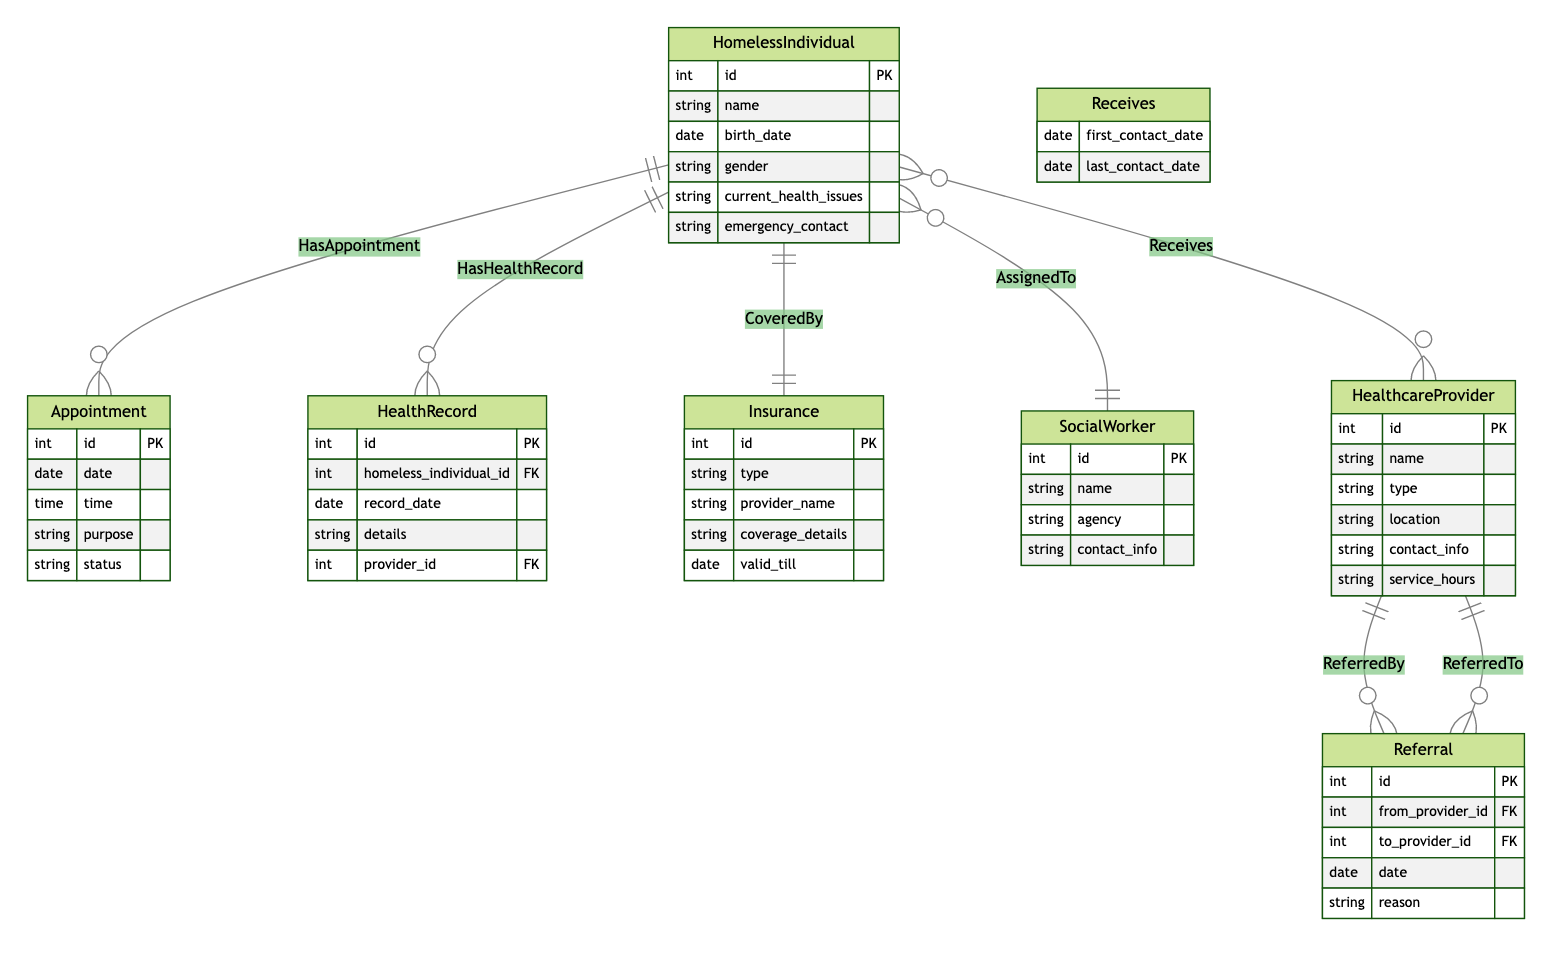What is the maximum number of Healthcare Providers a Homeless Individual can interact with? The diagram shows a many-to-many relationship between Homeless Individual and Healthcare Provider, indicating that one Homeless Individual can receive services from multiple Healthcare Providers and vice versa. Therefore, there is no defined maximum in the ERD, and it can be any number.
Answer: Many How many attributes does the Homeless Individual entity have? By reviewing the diagram, we can see that the Homeless Individual entity has six listed attributes: id, name, birth_date, gender, current_health_issues, and emergency_contact.
Answer: Six What is the relationship type between Homeless Individual and Insurance? The diagram specifies a one-to-one relationship between the Homeless Individual and Insurance entities, indicating that each Homeless Individual can be covered by one Insurance and vice versa.
Answer: One-to-one How many entities are involved in the referral process? The referral process involves three entities: Healthcare Provider (from_provider_id), Healthcare Provider (to_provider_id), and Referral entity connecting them. Therefore, both the referring provider and referred provider count as entities in this process.
Answer: Three Which entity contains information about social worker assignments? The Social Worker entity includes information on the assignments to Homeless Individuals, made evident by the many-to-one relationship, showing that multiple Homeless Individuals can be assigned to the same Social Worker.
Answer: Social Worker What attributes are found in the Appointment entity? The attributes in the Appointment entity include: id, date, time, purpose, and status, providing detailed information for scheduling appointments.
Answer: Five Which entity is responsible for maintaining health records? The Health Record entity is responsible for maintaining health records of Homeless Individuals, as illustrated by the one-to-many relationship with Homeless Individual.
Answer: Health Record What type of information does the Referral entity document? The Referral entity documents the relationships between Healthcare Providers including from_provider_id, to_provider_id, date, and reason, specifying details of healthcare transitions.
Answer: Healthcare transitions What indicates the frequency of contact between Homeless Individuals and Healthcare Providers? The relationship Receives includes “first_contact_date” and “last_contact_date” attributes, signifying the frequency of contact over time between the two entities in the healthcare system.
Answer: Contact dates 